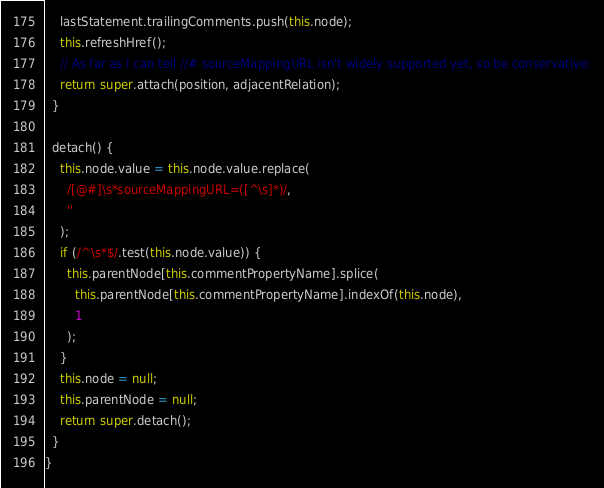<code> <loc_0><loc_0><loc_500><loc_500><_JavaScript_>    lastStatement.trailingComments.push(this.node);
    this.refreshHref();
    // As far as I can tell //# sourceMappingURL isn't widely supported yet, so be conservative:
    return super.attach(position, adjacentRelation);
  }

  detach() {
    this.node.value = this.node.value.replace(
      /[@#]\s*sourceMappingURL=([^\s]*)/,
      ''
    );
    if (/^\s*$/.test(this.node.value)) {
      this.parentNode[this.commentPropertyName].splice(
        this.parentNode[this.commentPropertyName].indexOf(this.node),
        1
      );
    }
    this.node = null;
    this.parentNode = null;
    return super.detach();
  }
}
</code> 